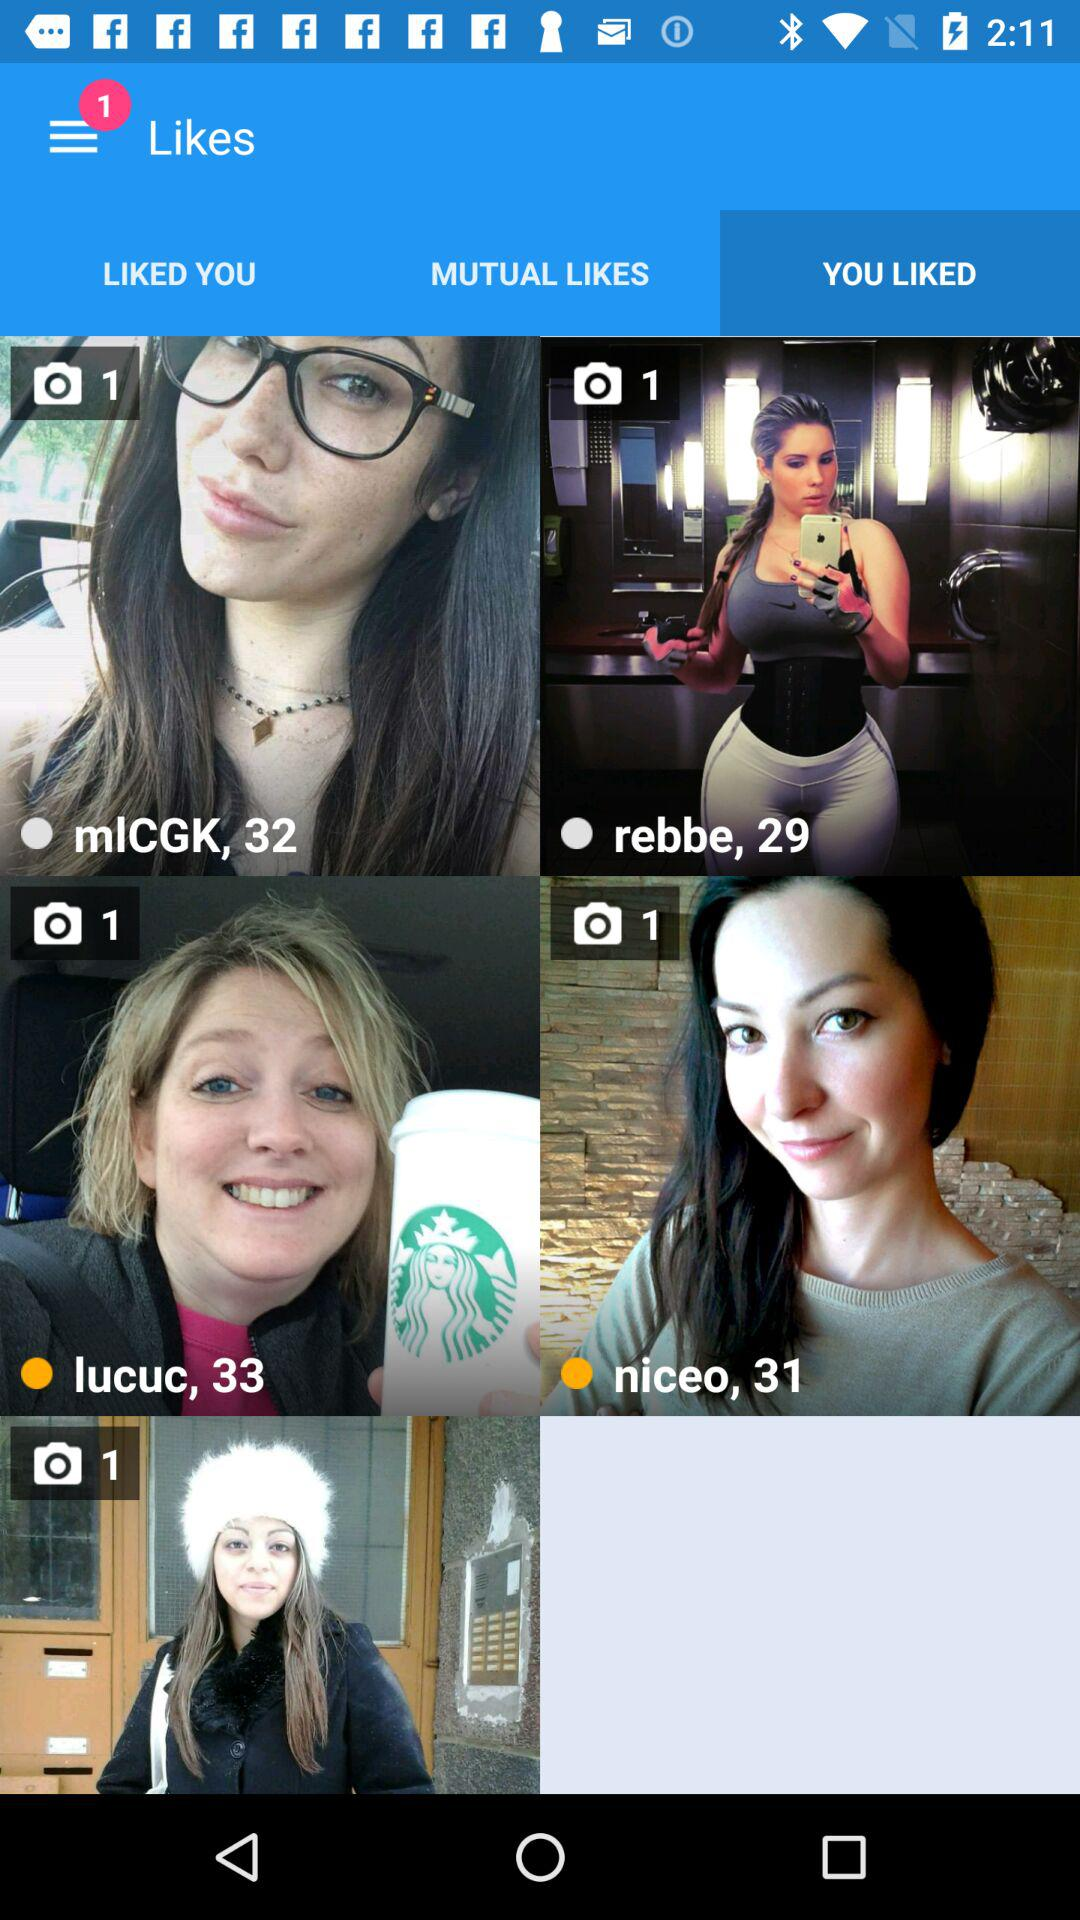Which tab is selected? The selected tab is "YOU LIKED". 